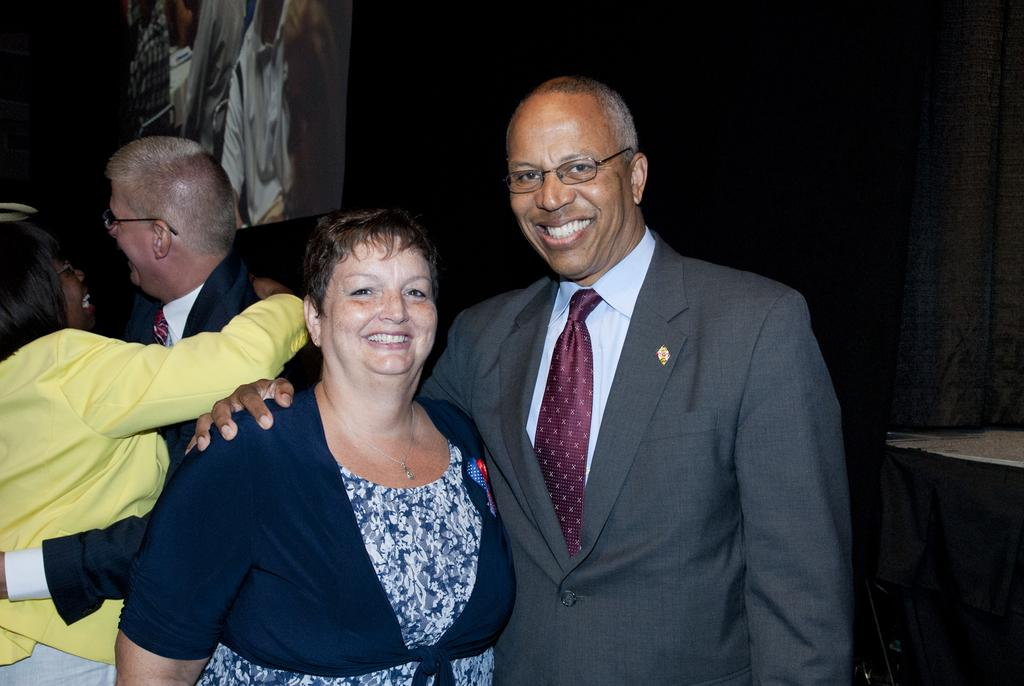Who is present in the image? There is a man and a woman in the image. What are the expressions on their faces? Both the man and the woman are smiling. What can be observed about the man in the foreground? The man is wearing glasses (specs). What is happening in the background of the image? There is another man and woman in the background, and they are holding each other. What can be seen on the man and woman in the background? Both the man and the woman in the background are wearing glasses (specs). What is visible in the background of the image? There is a screen visible in the background. What type of paint is being used by the man in the image? There is no paint or painting activity present in the image. How many shoes can be seen on the woman in the image? There is no mention of shoes in the image; the focus is on the people and their expressions and glasses. 